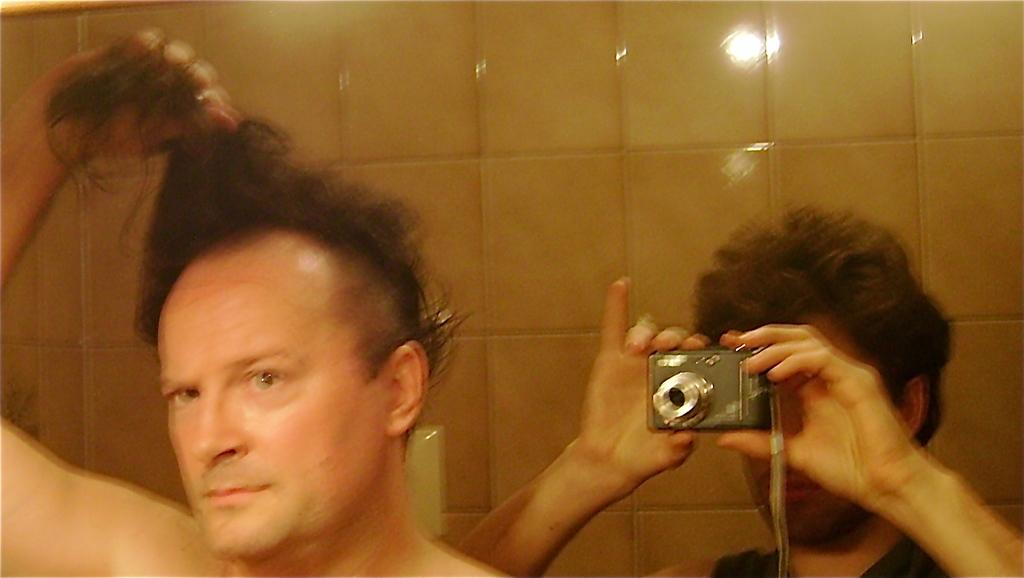What is the man on the left side of the image doing? The man on the left side of the image is holding his hair. Who is capturing the man on the left side of the image? There is a person capturing the man on the right side of the image. What can be seen in the background of the image? There is a wall visible in the background of the image. What type of hammer is being used to capture the man in the image? There is no hammer present in the image; the person capturing the man is using a camera or a similar device. 